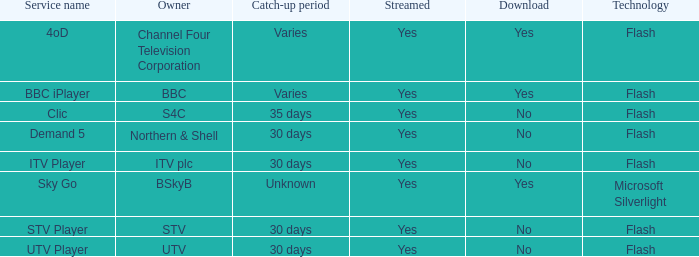What is the Catch-up period for UTV? 30 days. 